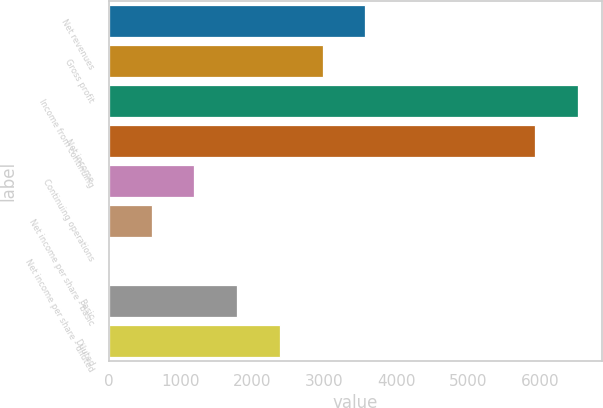<chart> <loc_0><loc_0><loc_500><loc_500><bar_chart><fcel>Net revenues<fcel>Gross profit<fcel>Income from continuing<fcel>Net income<fcel>Continuing operations<fcel>Net income per share - basic<fcel>Net income per share - diluted<fcel>Basic<fcel>Diluted<nl><fcel>3570.92<fcel>2976.65<fcel>6530.27<fcel>5936<fcel>1193.84<fcel>599.57<fcel>5.3<fcel>1788.11<fcel>2382.38<nl></chart> 